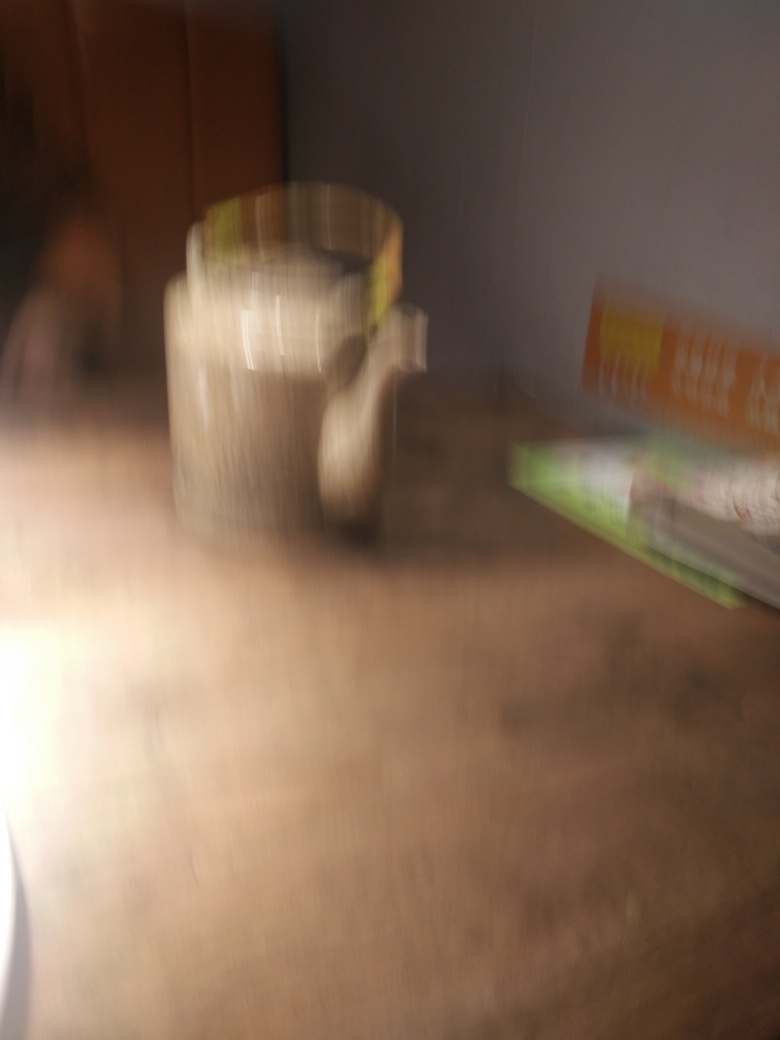What might be the subject in the center of this image? While the subject is not clear due to the blurriness, based on its general shape and contours, it could potentially be a cup or mug situated on a surface. 